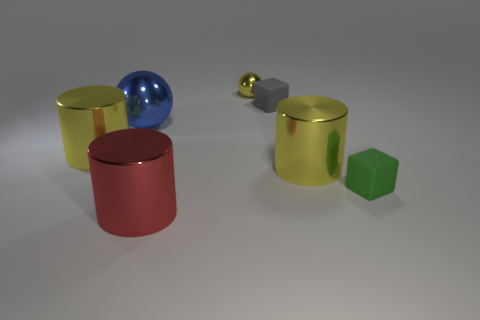Do the big object on the left side of the large blue metallic sphere and the yellow ball have the same material?
Ensure brevity in your answer.  Yes. There is a yellow metallic thing right of the small yellow object that is behind the small gray cube; what size is it?
Provide a succinct answer. Large. What size is the green block in front of the yellow shiny object to the right of the ball that is right of the big red shiny cylinder?
Provide a short and direct response. Small. Does the shiny object on the right side of the gray block have the same shape as the yellow shiny object that is on the left side of the large red cylinder?
Ensure brevity in your answer.  Yes. How many other objects are the same color as the tiny ball?
Keep it short and to the point. 2. There is a matte cube behind the green matte block; does it have the same size as the red cylinder?
Your answer should be very brief. No. Does the yellow thing that is left of the big ball have the same material as the ball behind the gray block?
Keep it short and to the point. Yes. Are there any red metallic things that have the same size as the red cylinder?
Offer a terse response. No. What is the shape of the tiny rubber object behind the object that is right of the yellow object to the right of the small yellow object?
Your response must be concise. Cube. Is the number of large objects that are to the left of the small metallic thing greater than the number of big purple objects?
Your answer should be very brief. Yes. 